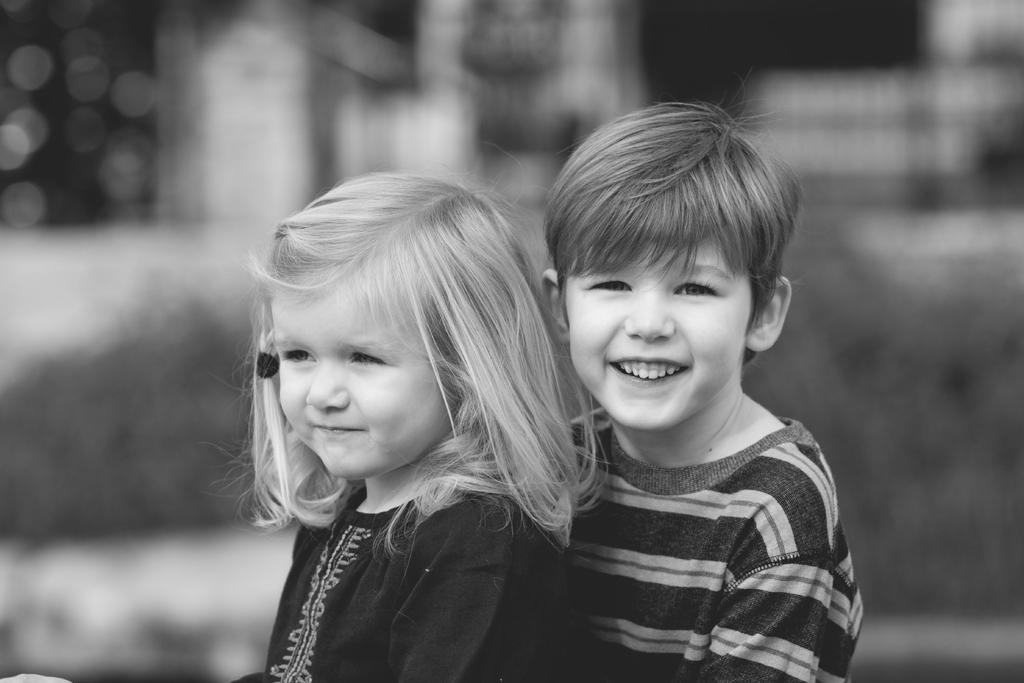How many children are present in the image? There are two kids in the image. What can be observed about the background of the image? The background of the image is blurred. What color scheme is used in the image? The image is in black and white. What type of marble is visible in the image? There is no marble present in the image. Are the kids causing any trouble in the image? The image does not provide any information about the kids' behavior, so it cannot be determined if they are causing trouble. 